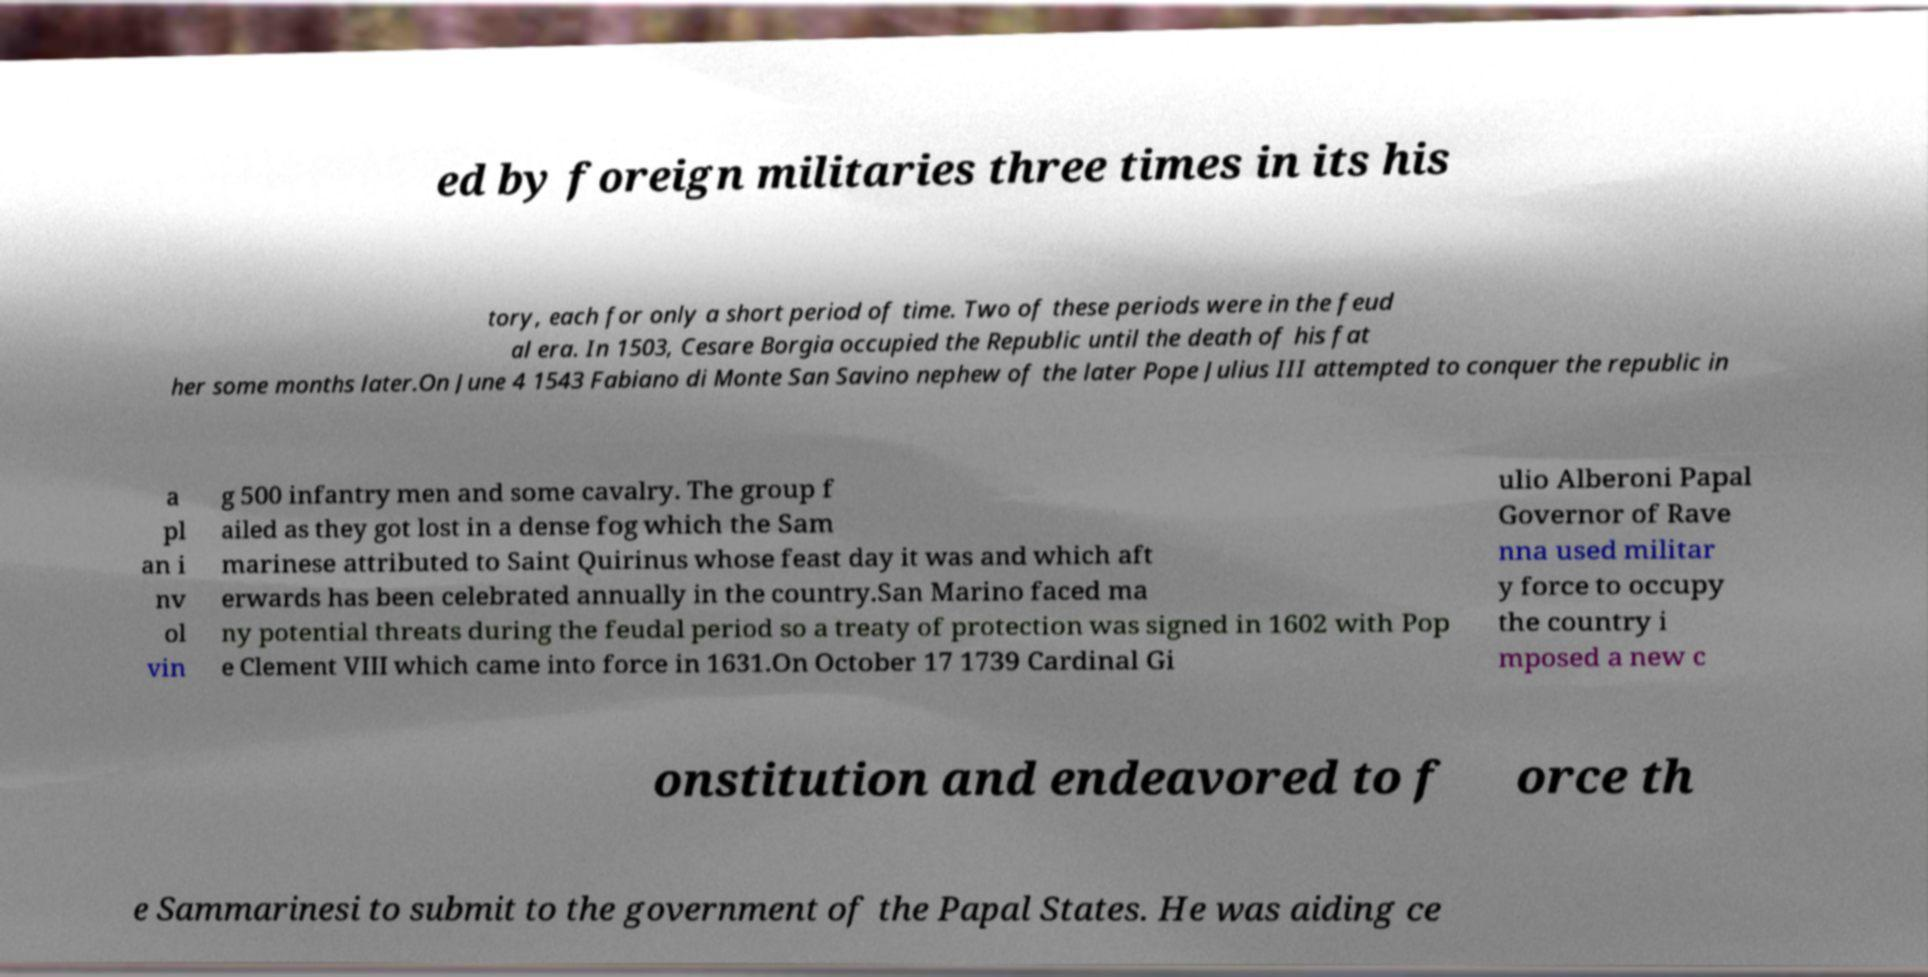There's text embedded in this image that I need extracted. Can you transcribe it verbatim? ed by foreign militaries three times in its his tory, each for only a short period of time. Two of these periods were in the feud al era. In 1503, Cesare Borgia occupied the Republic until the death of his fat her some months later.On June 4 1543 Fabiano di Monte San Savino nephew of the later Pope Julius III attempted to conquer the republic in a pl an i nv ol vin g 500 infantry men and some cavalry. The group f ailed as they got lost in a dense fog which the Sam marinese attributed to Saint Quirinus whose feast day it was and which aft erwards has been celebrated annually in the country.San Marino faced ma ny potential threats during the feudal period so a treaty of protection was signed in 1602 with Pop e Clement VIII which came into force in 1631.On October 17 1739 Cardinal Gi ulio Alberoni Papal Governor of Rave nna used militar y force to occupy the country i mposed a new c onstitution and endeavored to f orce th e Sammarinesi to submit to the government of the Papal States. He was aiding ce 